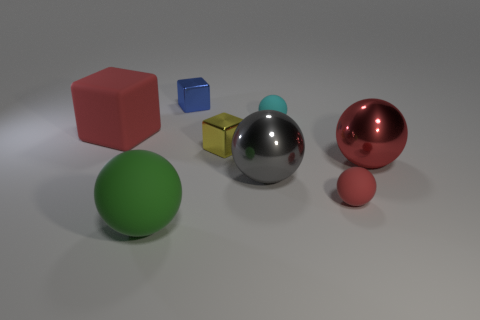There is a tiny object that is the same color as the big rubber cube; what is its material?
Your answer should be compact. Rubber. Is the size of the metal block in front of the big red rubber object the same as the cube that is on the left side of the blue block?
Provide a succinct answer. No. What shape is the shiny thing on the right side of the red matte ball?
Keep it short and to the point. Sphere. There is another small object that is the same shape as the blue thing; what material is it?
Offer a terse response. Metal. There is a block left of the blue cube; is it the same size as the yellow thing?
Your answer should be very brief. No. How many rubber spheres are in front of the tiny cyan matte object?
Your answer should be very brief. 2. Is the number of big green rubber balls that are behind the tiny blue block less than the number of yellow objects that are behind the big rubber cube?
Keep it short and to the point. No. How many small metallic cylinders are there?
Your response must be concise. 0. What is the color of the cube that is on the left side of the small blue shiny object?
Offer a very short reply. Red. How big is the yellow object?
Give a very brief answer. Small. 